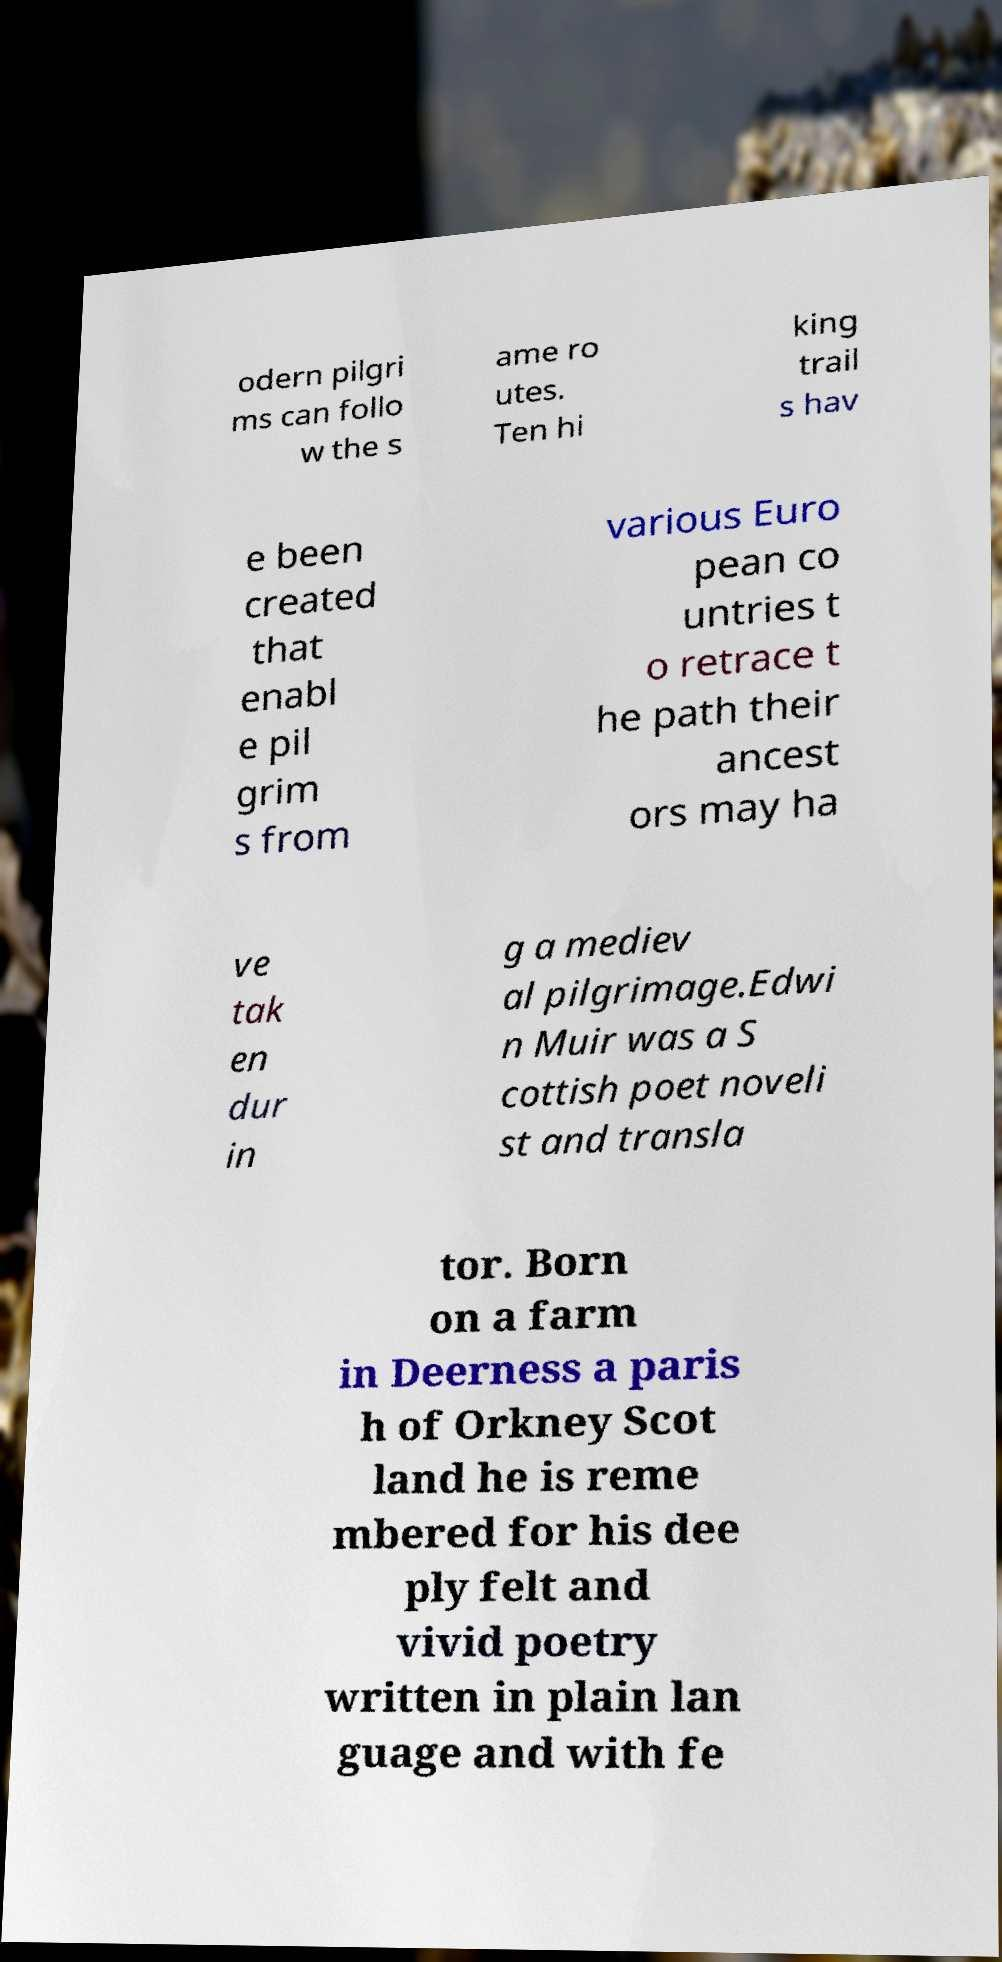I need the written content from this picture converted into text. Can you do that? odern pilgri ms can follo w the s ame ro utes. Ten hi king trail s hav e been created that enabl e pil grim s from various Euro pean co untries t o retrace t he path their ancest ors may ha ve tak en dur in g a mediev al pilgrimage.Edwi n Muir was a S cottish poet noveli st and transla tor. Born on a farm in Deerness a paris h of Orkney Scot land he is reme mbered for his dee ply felt and vivid poetry written in plain lan guage and with fe 